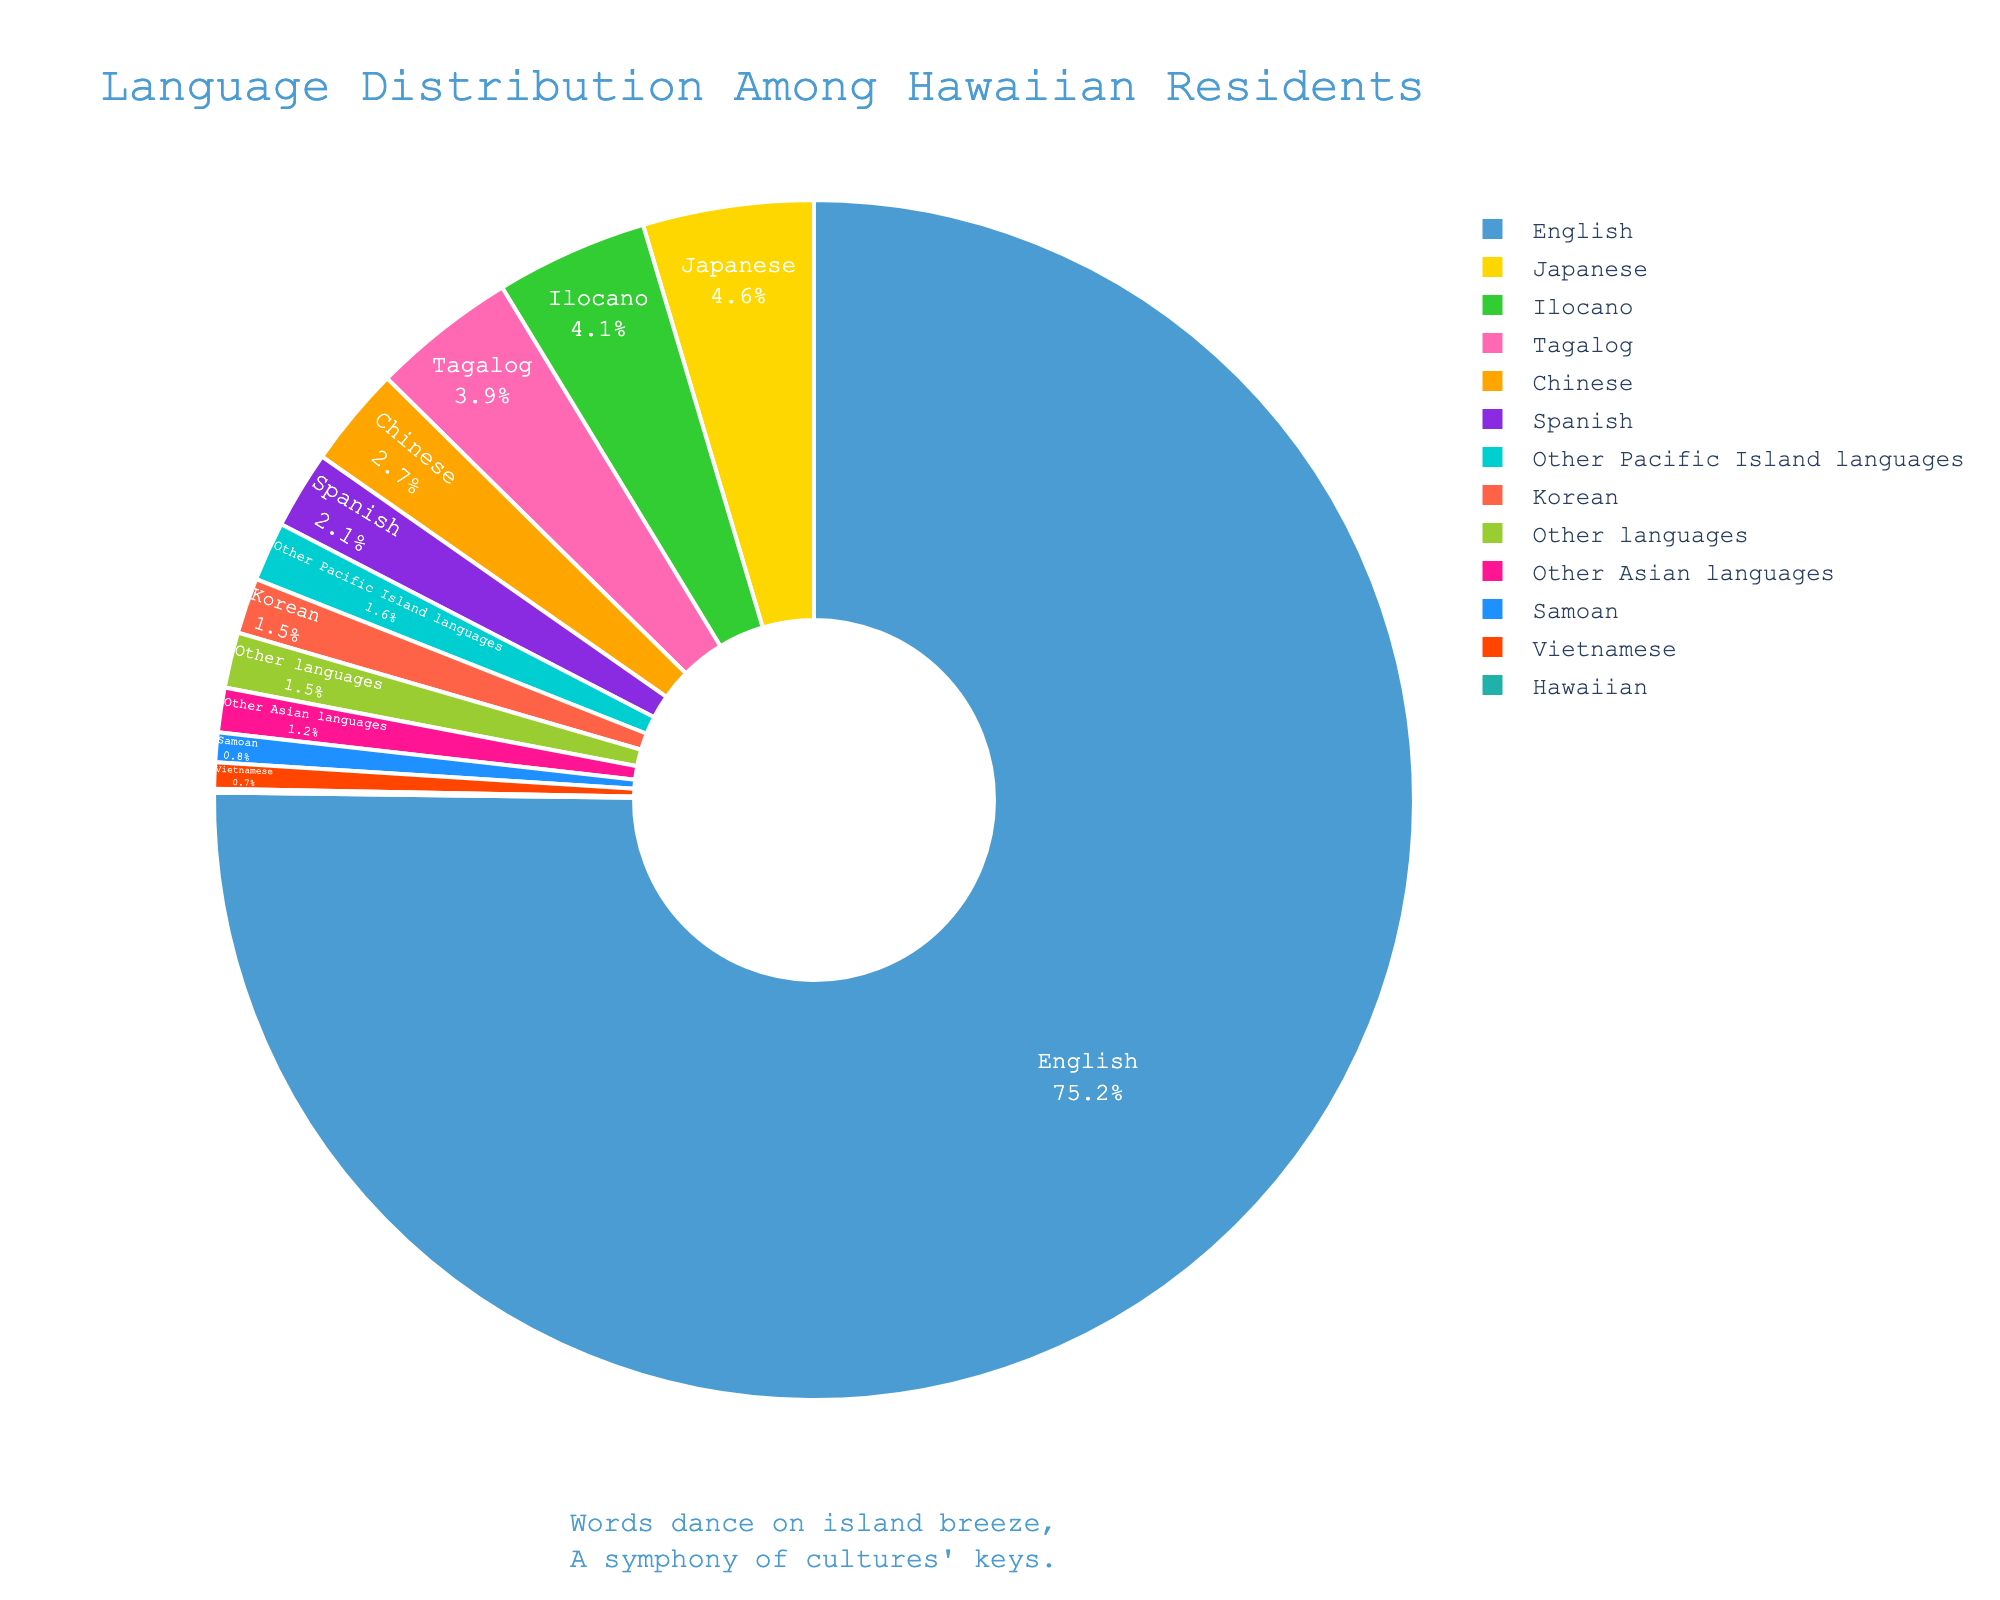What's the percentage of residents who speak Tagalog and Vietnamese combined? To find the combined percentage of residents who speak Tagalog and Vietnamese, sum the individual percentages: 3.9% (Tagalog) + 0.7% (Vietnamese) = 4.6%.
Answer: 4.6% Which language has a higher percentage of speakers, Japanese or Ilocano? The percentage of Japanese speakers is 4.6%, while the percentage of Ilocano speakers is 4.1%. Since 4.6% is greater than 4.1%, Japanese has a higher percentage of speakers than Ilocano.
Answer: Japanese How does the percentage of Hawaiian speakers compare to the aggregate percentage of all other Pacific Island languages combined (excluding Hawaiian)? The percentage of Hawaiian speakers is 0.1%. Other Pacific Island languages collectively make up 1.6%. Since 1.6% is greater than 0.1%, the aggregate percentage of all other Pacific Island languages combined is higher.
Answer: Other Pacific Island languages What is the most commonly spoken language? By looking at the pie chart, we can see that the largest segment represents English with a percentage of 75.2%.
Answer: English Which language segment is represented with the green color in the pie chart? The green color in the pie chart represents the Ilocano language.
Answer: Ilocano What is the subtotal percentage of Asian languages (Japanese, Chinese, Korean, Vietnamese) combined? Sum the percentages of Japanese (4.6%), Chinese (2.7%), Korean (1.5%), and Vietnamese (0.7%): 4.6% + 2.7% + 1.5% + 0.7% = 9.5%.
Answer: 9.5% Of the languages represented, which two share the smallest percentage on the pie chart? Hawaiian and Vietnamese both have very low percentages, but Hawaiian has the smallest at 0.1%. The second smallest percentage is for Vietnamese at 0.7%.
Answer: Hawaiian and Vietnamese How do the percentages of speakers of Spanish and Samoan compare? Spanish speakers make up 2.1%, while Samoan speakers make up 0.8%. Therefore, the percentage of Spanish speakers is higher.
Answer: Spanish If you combine the percentages of residents who speak Korean, Chinese, and other Asian languages, how does it compare to the percentage of Japanese speakers? Korean (1.5%), Chinese (2.7%), and other Asian languages (1.2%) sum up to 5.4%. Since Japanese speakers make up 4.6%, the combined percentage (5.4%) of Korean, Chinese, and other Asian languages is higher than that of Japanese speakers.
Answer: Combined percentage is higher What percentage of residents speak languages other than the four most commonly spoken ones (English, Japanese, Ilocano, Tagalog)? The four most commonly spoken languages total: English (75.2%) + Japanese (4.6%) + Ilocano (4.1%) + Tagalog (3.9%) = 87.8%. Therefore, residents speaking other languages would be 100% - 87.8% = 12.2%.
Answer: 12.2% 